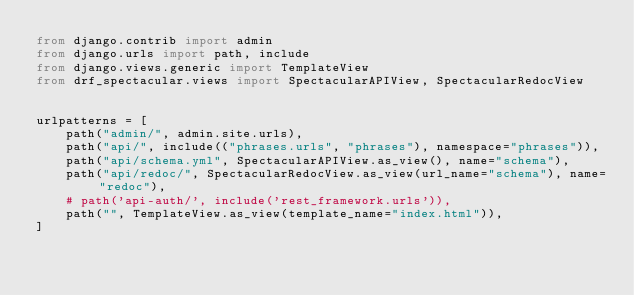Convert code to text. <code><loc_0><loc_0><loc_500><loc_500><_Python_>from django.contrib import admin
from django.urls import path, include
from django.views.generic import TemplateView
from drf_spectacular.views import SpectacularAPIView, SpectacularRedocView


urlpatterns = [
    path("admin/", admin.site.urls),
    path("api/", include(("phrases.urls", "phrases"), namespace="phrases")),
    path("api/schema.yml", SpectacularAPIView.as_view(), name="schema"),
    path("api/redoc/", SpectacularRedocView.as_view(url_name="schema"), name="redoc"),
    # path('api-auth/', include('rest_framework.urls')),
    path("", TemplateView.as_view(template_name="index.html")),
]
</code> 